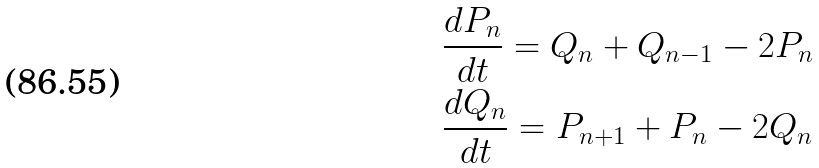Convert formula to latex. <formula><loc_0><loc_0><loc_500><loc_500>& \frac { d P _ { n } } { d t } = Q _ { n } + Q _ { n - 1 } - 2 P _ { n } \\ & \frac { d Q _ { n } } { d t } = P _ { n + 1 } + P _ { n } - 2 Q _ { n }</formula> 